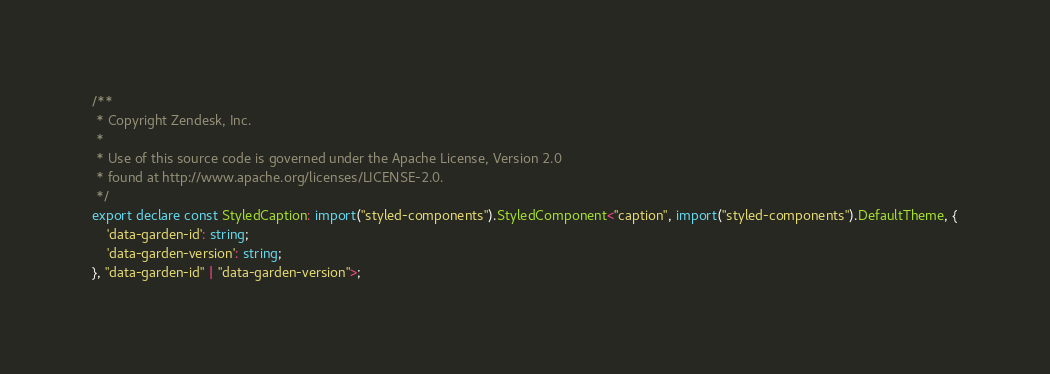Convert code to text. <code><loc_0><loc_0><loc_500><loc_500><_TypeScript_>/**
 * Copyright Zendesk, Inc.
 *
 * Use of this source code is governed under the Apache License, Version 2.0
 * found at http://www.apache.org/licenses/LICENSE-2.0.
 */
export declare const StyledCaption: import("styled-components").StyledComponent<"caption", import("styled-components").DefaultTheme, {
    'data-garden-id': string;
    'data-garden-version': string;
}, "data-garden-id" | "data-garden-version">;
</code> 